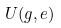Convert formula to latex. <formula><loc_0><loc_0><loc_500><loc_500>U ( g , e )</formula> 